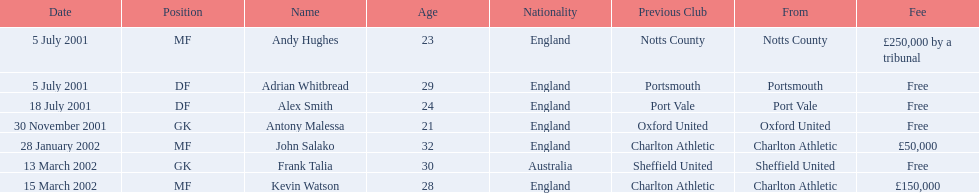Who were all the players? Andy Hughes, Adrian Whitbread, Alex Smith, Antony Malessa, John Salako, Frank Talia, Kevin Watson. What were the transfer fees of these players? £250,000 by a tribunal, Free, Free, Free, £50,000, Free, £150,000. Of these, which belong to andy hughes and john salako? £250,000 by a tribunal, £50,000. Of these, which is larger? £250,000 by a tribunal. Which player commanded this fee? Andy Hughes. 